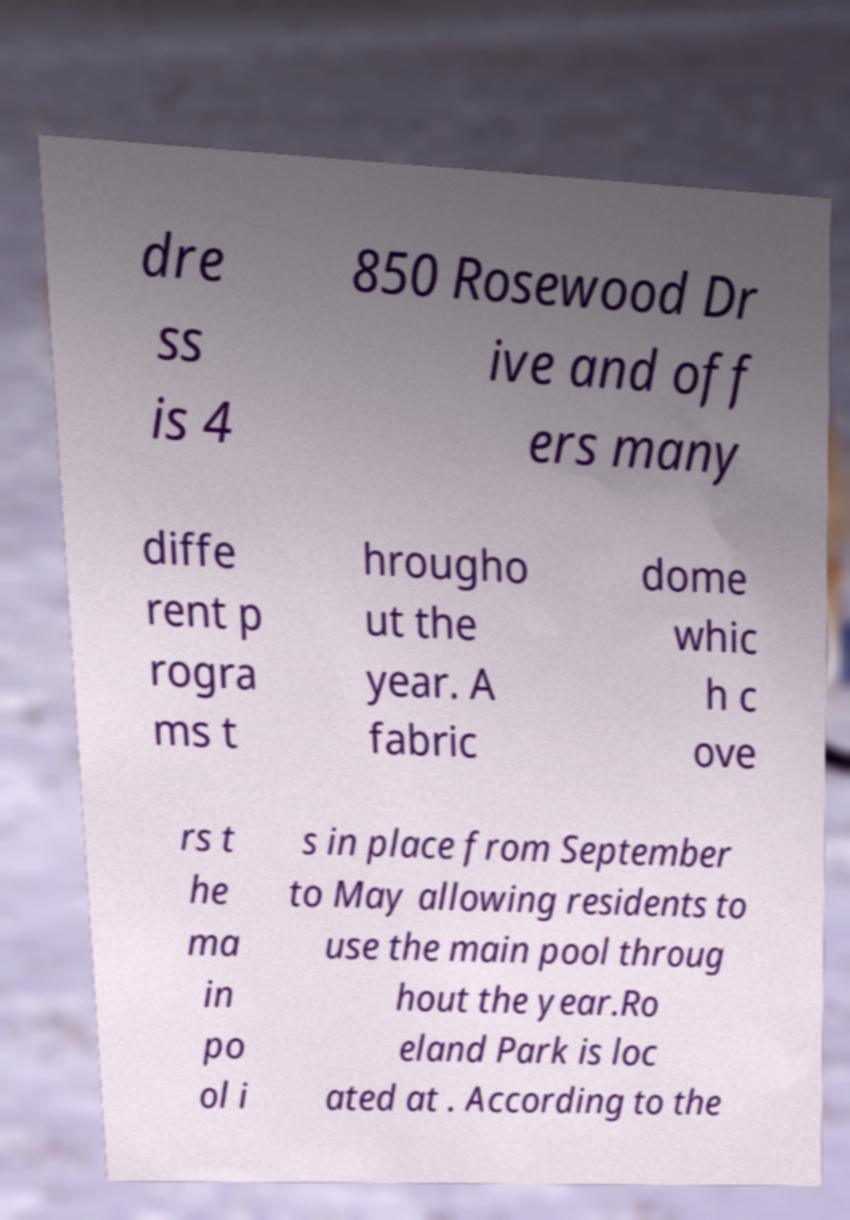Could you assist in decoding the text presented in this image and type it out clearly? dre ss is 4 850 Rosewood Dr ive and off ers many diffe rent p rogra ms t hrougho ut the year. A fabric dome whic h c ove rs t he ma in po ol i s in place from September to May allowing residents to use the main pool throug hout the year.Ro eland Park is loc ated at . According to the 